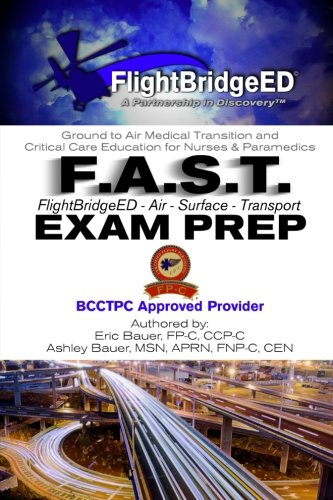What specific certifications does this book prepare the reader for? This book prepares readers for certifications related to air and surface transport medical care, such as those offered by BCCTPC (Board for Critical Care Transport Paramedic Certification). 